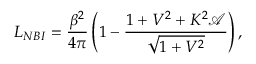<formula> <loc_0><loc_0><loc_500><loc_500>L _ { N B I } = \frac { \beta ^ { 2 } } { 4 \pi } \left ( 1 - \frac { 1 + V ^ { 2 } + K ^ { 2 } \mathcal { A } } { \sqrt { 1 + V ^ { 2 } } } \right ) ,</formula> 